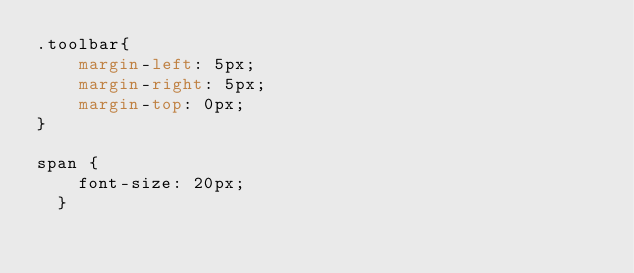<code> <loc_0><loc_0><loc_500><loc_500><_CSS_>.toolbar{
    margin-left: 5px;
    margin-right: 5px;
    margin-top: 0px;
}

span {
    font-size: 20px;
  }</code> 